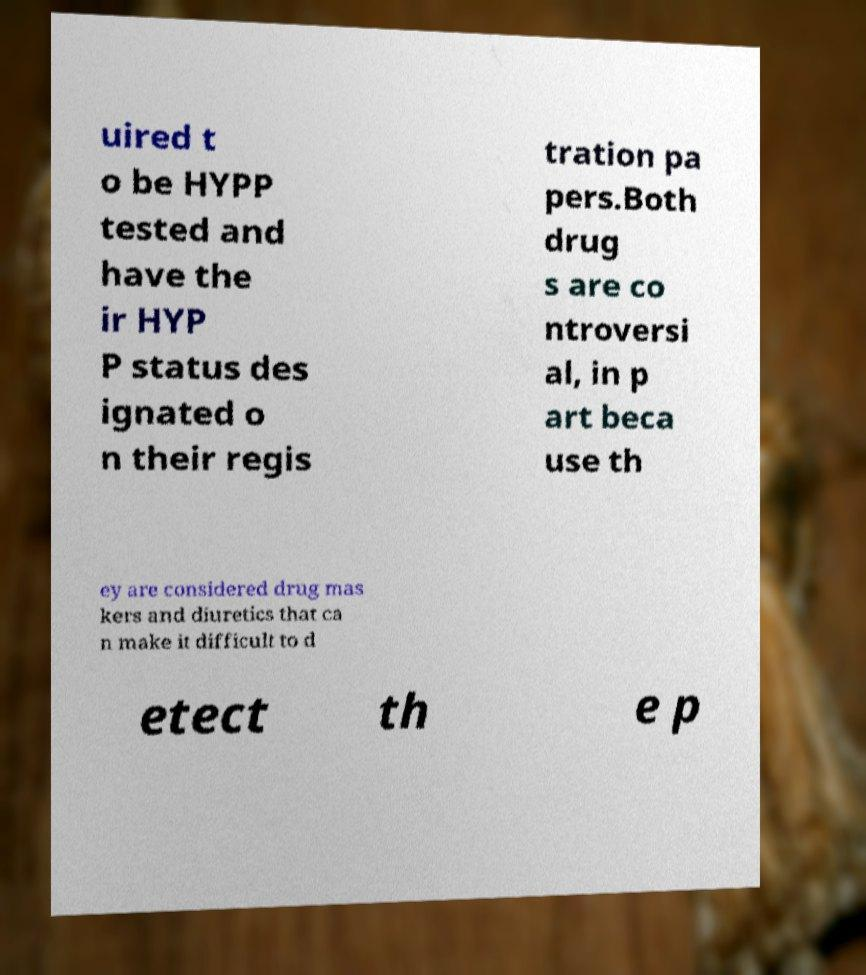Could you extract and type out the text from this image? uired t o be HYPP tested and have the ir HYP P status des ignated o n their regis tration pa pers.Both drug s are co ntroversi al, in p art beca use th ey are considered drug mas kers and diuretics that ca n make it difficult to d etect th e p 